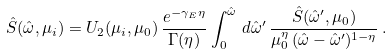<formula> <loc_0><loc_0><loc_500><loc_500>\hat { S } ( \hat { \omega } , \mu _ { i } ) = U _ { 2 } ( \mu _ { i } , \mu _ { 0 } ) \, \frac { e ^ { - \gamma _ { E } \eta } } { \Gamma ( \eta ) } \int _ { 0 } ^ { \hat { \omega } } \, d \hat { \omega } ^ { \prime } \, \frac { \hat { S } ( \hat { \omega } ^ { \prime } , \mu _ { 0 } ) } { \mu _ { 0 } ^ { \eta } \, ( \hat { \omega } - \hat { \omega } ^ { \prime } ) ^ { 1 - \eta } } \, .</formula> 